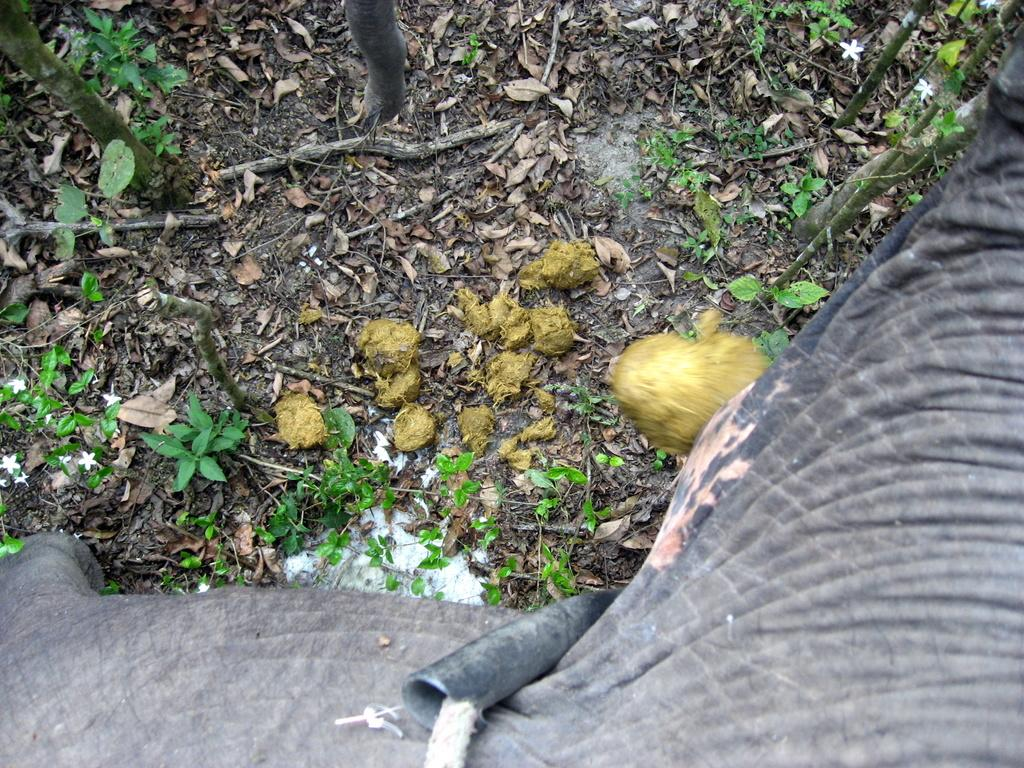What type of natural elements can be seen in the image? There are plants and leaves in the image. What animal is present at the bottom of the image? There appears to be an elephant at the bottom of the image. What objects can be seen at the bottom of the image? A rope and a pipe are visible at the bottom of the image. What type of vase is holding the plants and leaves in the image? There is no vase present in the image; the plants and leaves are not contained in a vase. How is the bucket used in the image? There is no bucket present in the image, so it cannot be used for any purpose in the image. 